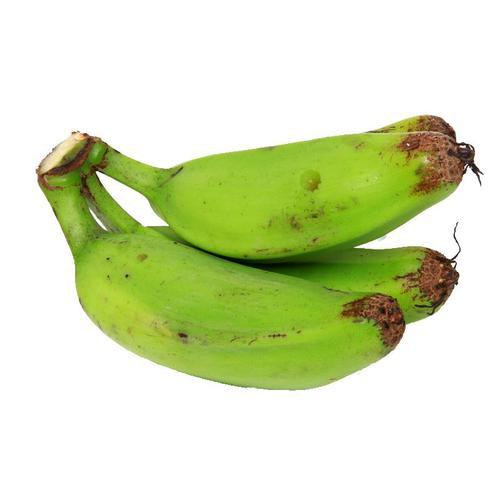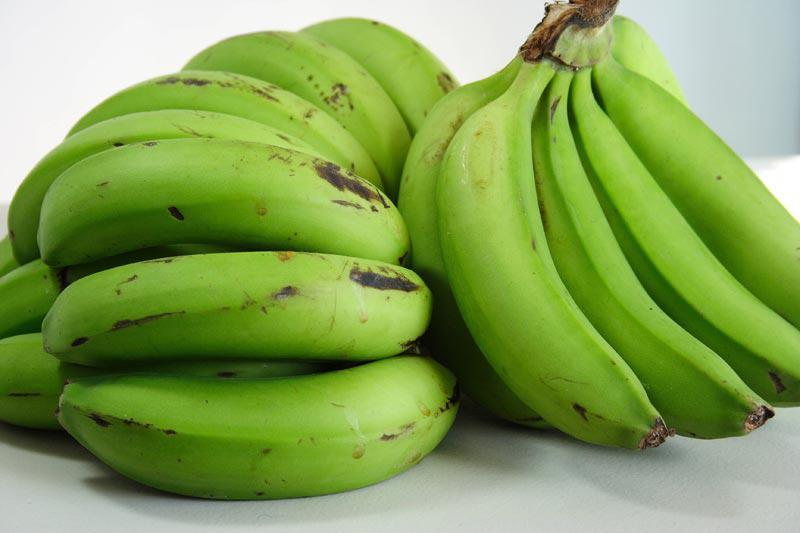The first image is the image on the left, the second image is the image on the right. Given the left and right images, does the statement "An image contains no more than three bananas, and the bananas have some brownish patches." hold true? Answer yes or no. Yes. The first image is the image on the left, the second image is the image on the right. Given the left and right images, does the statement "One image contains three or less plantains, the other contains more than six bananas." hold true? Answer yes or no. Yes. 